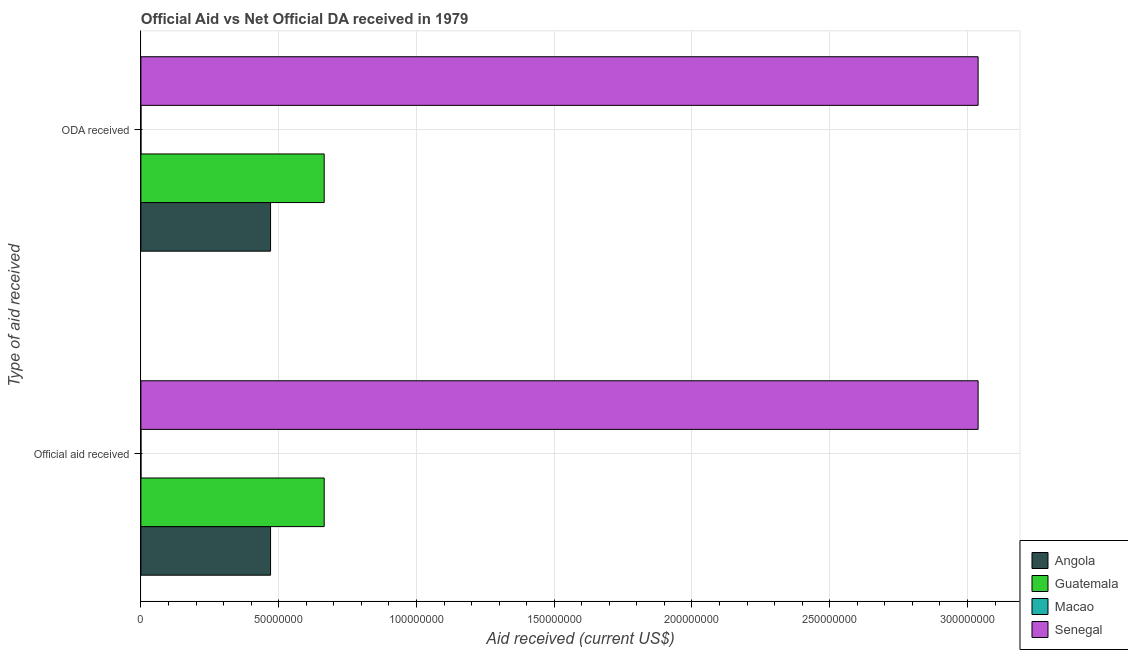How many different coloured bars are there?
Provide a succinct answer. 4. How many groups of bars are there?
Offer a terse response. 2. How many bars are there on the 2nd tick from the top?
Make the answer very short. 4. How many bars are there on the 1st tick from the bottom?
Offer a very short reply. 4. What is the label of the 2nd group of bars from the top?
Keep it short and to the point. Official aid received. What is the official aid received in Senegal?
Offer a very short reply. 3.04e+08. Across all countries, what is the maximum oda received?
Provide a succinct answer. 3.04e+08. Across all countries, what is the minimum oda received?
Offer a terse response. 2.00e+04. In which country was the official aid received maximum?
Offer a terse response. Senegal. In which country was the oda received minimum?
Your answer should be compact. Macao. What is the total oda received in the graph?
Make the answer very short. 4.17e+08. What is the difference between the official aid received in Guatemala and that in Macao?
Your answer should be compact. 6.65e+07. What is the difference between the official aid received in Macao and the oda received in Guatemala?
Your response must be concise. -6.65e+07. What is the average oda received per country?
Your response must be concise. 1.04e+08. What is the ratio of the official aid received in Macao to that in Senegal?
Offer a terse response. 6.582411795681937e-5. In how many countries, is the official aid received greater than the average official aid received taken over all countries?
Provide a short and direct response. 1. What does the 4th bar from the top in Official aid received represents?
Your answer should be very brief. Angola. What does the 4th bar from the bottom in Official aid received represents?
Offer a terse response. Senegal. How many countries are there in the graph?
Your answer should be compact. 4. What is the difference between two consecutive major ticks on the X-axis?
Provide a short and direct response. 5.00e+07. Does the graph contain grids?
Provide a succinct answer. Yes. What is the title of the graph?
Give a very brief answer. Official Aid vs Net Official DA received in 1979 . Does "Timor-Leste" appear as one of the legend labels in the graph?
Provide a short and direct response. No. What is the label or title of the X-axis?
Ensure brevity in your answer.  Aid received (current US$). What is the label or title of the Y-axis?
Offer a terse response. Type of aid received. What is the Aid received (current US$) of Angola in Official aid received?
Ensure brevity in your answer.  4.71e+07. What is the Aid received (current US$) in Guatemala in Official aid received?
Your response must be concise. 6.65e+07. What is the Aid received (current US$) of Senegal in Official aid received?
Provide a short and direct response. 3.04e+08. What is the Aid received (current US$) of Angola in ODA received?
Your response must be concise. 4.71e+07. What is the Aid received (current US$) of Guatemala in ODA received?
Keep it short and to the point. 6.65e+07. What is the Aid received (current US$) of Senegal in ODA received?
Your answer should be very brief. 3.04e+08. Across all Type of aid received, what is the maximum Aid received (current US$) in Angola?
Provide a succinct answer. 4.71e+07. Across all Type of aid received, what is the maximum Aid received (current US$) in Guatemala?
Your answer should be very brief. 6.65e+07. Across all Type of aid received, what is the maximum Aid received (current US$) of Macao?
Your answer should be compact. 2.00e+04. Across all Type of aid received, what is the maximum Aid received (current US$) in Senegal?
Make the answer very short. 3.04e+08. Across all Type of aid received, what is the minimum Aid received (current US$) in Angola?
Offer a very short reply. 4.71e+07. Across all Type of aid received, what is the minimum Aid received (current US$) of Guatemala?
Keep it short and to the point. 6.65e+07. Across all Type of aid received, what is the minimum Aid received (current US$) of Macao?
Provide a short and direct response. 2.00e+04. Across all Type of aid received, what is the minimum Aid received (current US$) in Senegal?
Your answer should be very brief. 3.04e+08. What is the total Aid received (current US$) in Angola in the graph?
Ensure brevity in your answer.  9.41e+07. What is the total Aid received (current US$) in Guatemala in the graph?
Make the answer very short. 1.33e+08. What is the total Aid received (current US$) in Senegal in the graph?
Give a very brief answer. 6.08e+08. What is the difference between the Aid received (current US$) of Angola in Official aid received and that in ODA received?
Keep it short and to the point. 0. What is the difference between the Aid received (current US$) in Angola in Official aid received and the Aid received (current US$) in Guatemala in ODA received?
Your response must be concise. -1.95e+07. What is the difference between the Aid received (current US$) in Angola in Official aid received and the Aid received (current US$) in Macao in ODA received?
Make the answer very short. 4.70e+07. What is the difference between the Aid received (current US$) of Angola in Official aid received and the Aid received (current US$) of Senegal in ODA received?
Keep it short and to the point. -2.57e+08. What is the difference between the Aid received (current US$) of Guatemala in Official aid received and the Aid received (current US$) of Macao in ODA received?
Ensure brevity in your answer.  6.65e+07. What is the difference between the Aid received (current US$) of Guatemala in Official aid received and the Aid received (current US$) of Senegal in ODA received?
Make the answer very short. -2.37e+08. What is the difference between the Aid received (current US$) in Macao in Official aid received and the Aid received (current US$) in Senegal in ODA received?
Ensure brevity in your answer.  -3.04e+08. What is the average Aid received (current US$) of Angola per Type of aid received?
Ensure brevity in your answer.  4.71e+07. What is the average Aid received (current US$) of Guatemala per Type of aid received?
Make the answer very short. 6.65e+07. What is the average Aid received (current US$) of Macao per Type of aid received?
Offer a very short reply. 2.00e+04. What is the average Aid received (current US$) in Senegal per Type of aid received?
Ensure brevity in your answer.  3.04e+08. What is the difference between the Aid received (current US$) in Angola and Aid received (current US$) in Guatemala in Official aid received?
Offer a terse response. -1.95e+07. What is the difference between the Aid received (current US$) in Angola and Aid received (current US$) in Macao in Official aid received?
Provide a succinct answer. 4.70e+07. What is the difference between the Aid received (current US$) in Angola and Aid received (current US$) in Senegal in Official aid received?
Your answer should be compact. -2.57e+08. What is the difference between the Aid received (current US$) in Guatemala and Aid received (current US$) in Macao in Official aid received?
Provide a short and direct response. 6.65e+07. What is the difference between the Aid received (current US$) in Guatemala and Aid received (current US$) in Senegal in Official aid received?
Provide a short and direct response. -2.37e+08. What is the difference between the Aid received (current US$) of Macao and Aid received (current US$) of Senegal in Official aid received?
Provide a short and direct response. -3.04e+08. What is the difference between the Aid received (current US$) of Angola and Aid received (current US$) of Guatemala in ODA received?
Provide a short and direct response. -1.95e+07. What is the difference between the Aid received (current US$) of Angola and Aid received (current US$) of Macao in ODA received?
Offer a very short reply. 4.70e+07. What is the difference between the Aid received (current US$) of Angola and Aid received (current US$) of Senegal in ODA received?
Your answer should be compact. -2.57e+08. What is the difference between the Aid received (current US$) of Guatemala and Aid received (current US$) of Macao in ODA received?
Offer a very short reply. 6.65e+07. What is the difference between the Aid received (current US$) in Guatemala and Aid received (current US$) in Senegal in ODA received?
Your response must be concise. -2.37e+08. What is the difference between the Aid received (current US$) in Macao and Aid received (current US$) in Senegal in ODA received?
Keep it short and to the point. -3.04e+08. What is the ratio of the Aid received (current US$) of Angola in Official aid received to that in ODA received?
Your answer should be very brief. 1. What is the ratio of the Aid received (current US$) in Guatemala in Official aid received to that in ODA received?
Your response must be concise. 1. What is the ratio of the Aid received (current US$) in Macao in Official aid received to that in ODA received?
Your answer should be compact. 1. What is the difference between the highest and the second highest Aid received (current US$) of Macao?
Your answer should be compact. 0. What is the difference between the highest and the lowest Aid received (current US$) in Angola?
Ensure brevity in your answer.  0. What is the difference between the highest and the lowest Aid received (current US$) of Senegal?
Keep it short and to the point. 0. 